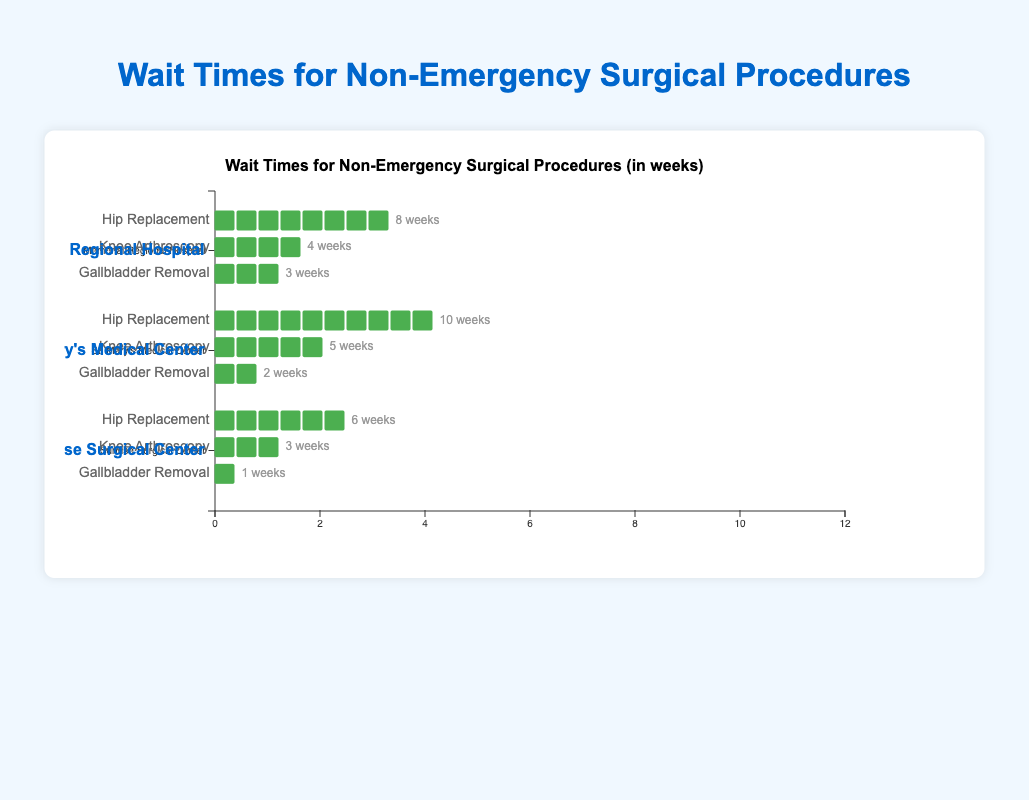How many weeks is the maximum wait time for a Hip Replacement at the three hospitals? The maximum wait times for Hip Replacement are shown by the green icons. Memorial Regional Hospital has 8 weeks, St. Mary’s Medical Center has 10 weeks, and Sunrise Surgical Center has 6 weeks. The maximum of these values is 10 weeks.
Answer: 10 weeks Which procedure has the shortest wait time at Sunrise Surgical Center? The shortest wait times can be determined by the number of green icons for each procedure. At Sunrise Surgical Center, the wait times are shown as 6 weeks for Hip Replacement, 3 weeks for Knee Arthroscopy, and 1 week for Gallbladder Removal. The shortest wait time is 1 week for Gallbladder Removal.
Answer: Gallbladder Removal What is the total wait time for all procedures (added together) at Memorial Regional Hospital? Adding the wait times for each procedure at Memorial Regional Hospital: 8 weeks for Hip Replacement, 4 weeks for Knee Arthroscopy, and 3 weeks for Gallbladder Removal. The total wait time is 8 + 4 + 3 = 15 weeks.
Answer: 15 weeks Which hospital has the shortest average wait time for Gallbladder Removal procedures? The wait times for Gallbladder Removal are 3 weeks at Memorial Regional Hospital, 2 weeks at St. Mary's Medical Center, and 1 week at Sunrise Surgical Center. The shortest average wait time is at Sunrise Surgical Center, with 1 week.
Answer: Sunrise Surgical Center How does the wait time for Knee Arthroscopy at St. Mary’s Medical Center compare to that at Memorial Regional Hospital? The wait times for Knee Arthroscopy are 5 weeks at St. Mary’s Medical Center and 4 weeks at Memorial Regional Hospital. St. Mary’s Medical Center has a longer wait time by 1 week.
Answer: St. Mary’s Medical Center has a longer wait time by 1 week What is the difference in wait time for Hip Replacement between Memorial Regional Hospital and Sunrise Surgical Center? The wait times for Hip Replacement are 8 weeks at Memorial Regional Hospital and 6 weeks at Sunrise Surgical Center. The difference is 8 - 6 = 2 weeks.
Answer: 2 weeks Rank the hospitals from shortest to longest average wait time for all procedures. To find the average wait time for each hospital, we add the wait times for all procedures and divide by the number of procedures:
Memorial Regional Hospital: (8+4+3)/3 = 5 weeks.
St. Mary's Medical Center: (10+5+2)/3 ≈ 5.67 weeks.
Sunrise Surgical Center: (6+3+1)/3 ≈ 3.33 weeks.
Ranking them from shortest to longest average wait time: Sunrise Surgical Center, Memorial Regional Hospital, St. Mary's Medical Center.
Answer: Sunrise Surgical Center, Memorial Regional Hospital, St. Mary's Medical Center 